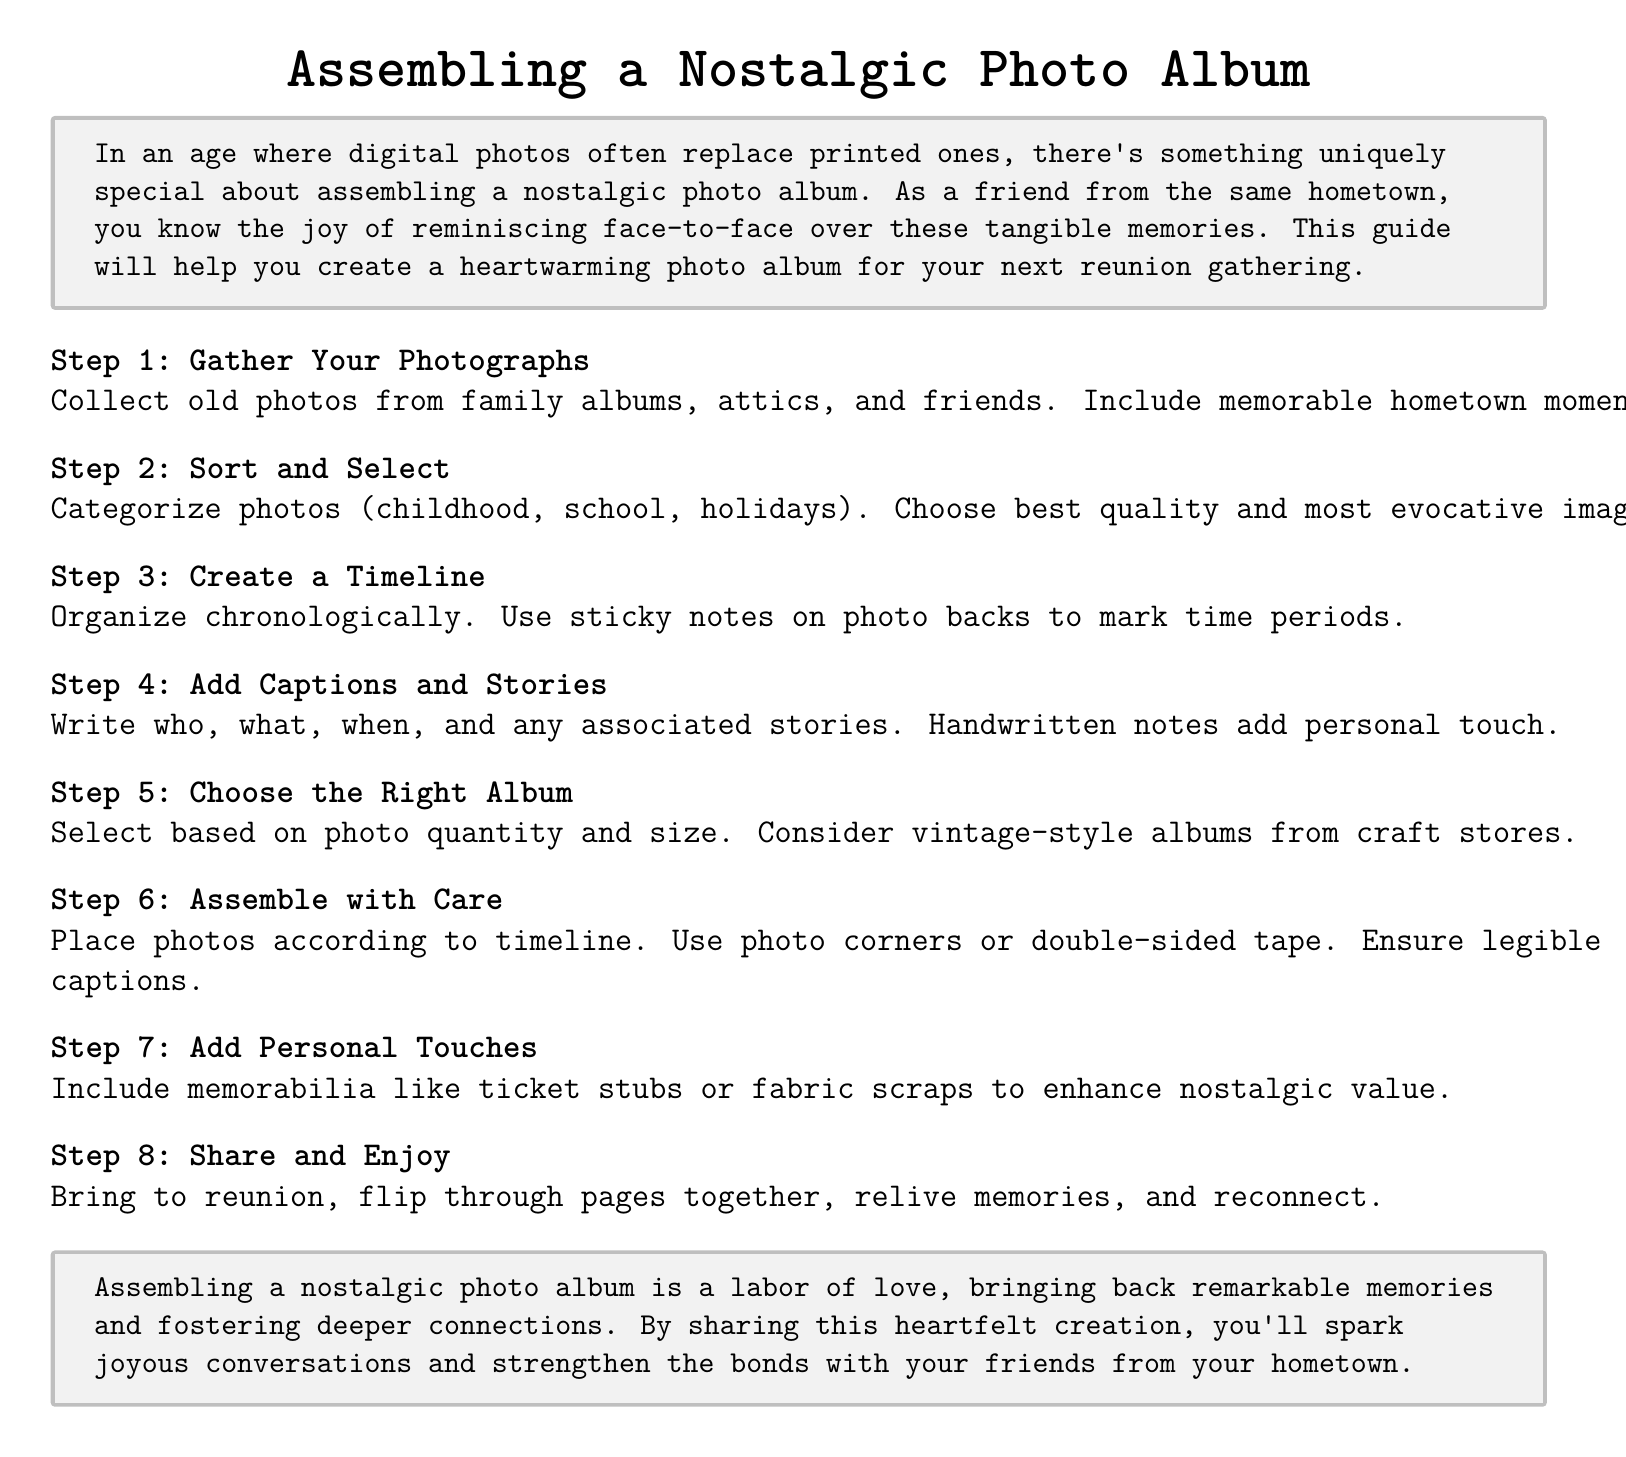What is the first step in assembling the photo album? The first step listed in the instructions is to gather photographs from various sources.
Answer: Gather Your Photographs How should photographs be categorized? The document suggests categorizing photos into specific themes like childhood and holidays.
Answer: Categorize photos What type of notes are recommended for marking time periods? The document mentions using sticky notes on the backs of photos to indicate time periods.
Answer: Sticky notes What should be included along with photographs to enhance nostalgic value? The guide suggests adding memorabilia like ticket stubs or fabric scraps.
Answer: Memorabilia What is the final step listed in the instructions? The last step instructs to share the assembled album at the reunion and enjoy the memories.
Answer: Share and Enjoy Why is handwritten notes recommended for captions? Handwritten notes add a personal touch to the album, making it more meaningful.
Answer: Personal touch What should be considered when choosing an album? The document advises selecting an album based on the quantity and size of the photos.
Answer: Photo quantity and size How can one categorize memories effectively in the album? Organizing the photos chronologically is recommended for effective categorization.
Answer: Organize chronologically 